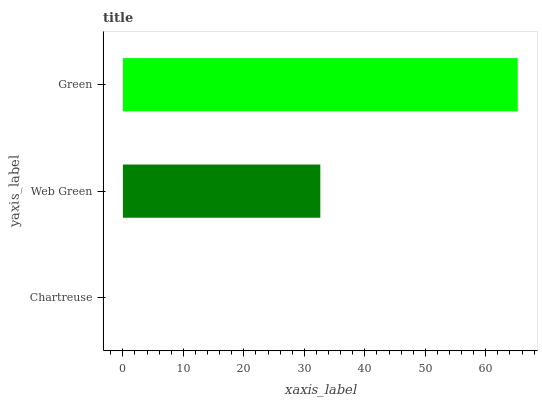Is Chartreuse the minimum?
Answer yes or no. Yes. Is Green the maximum?
Answer yes or no. Yes. Is Web Green the minimum?
Answer yes or no. No. Is Web Green the maximum?
Answer yes or no. No. Is Web Green greater than Chartreuse?
Answer yes or no. Yes. Is Chartreuse less than Web Green?
Answer yes or no. Yes. Is Chartreuse greater than Web Green?
Answer yes or no. No. Is Web Green less than Chartreuse?
Answer yes or no. No. Is Web Green the high median?
Answer yes or no. Yes. Is Web Green the low median?
Answer yes or no. Yes. Is Chartreuse the high median?
Answer yes or no. No. Is Chartreuse the low median?
Answer yes or no. No. 